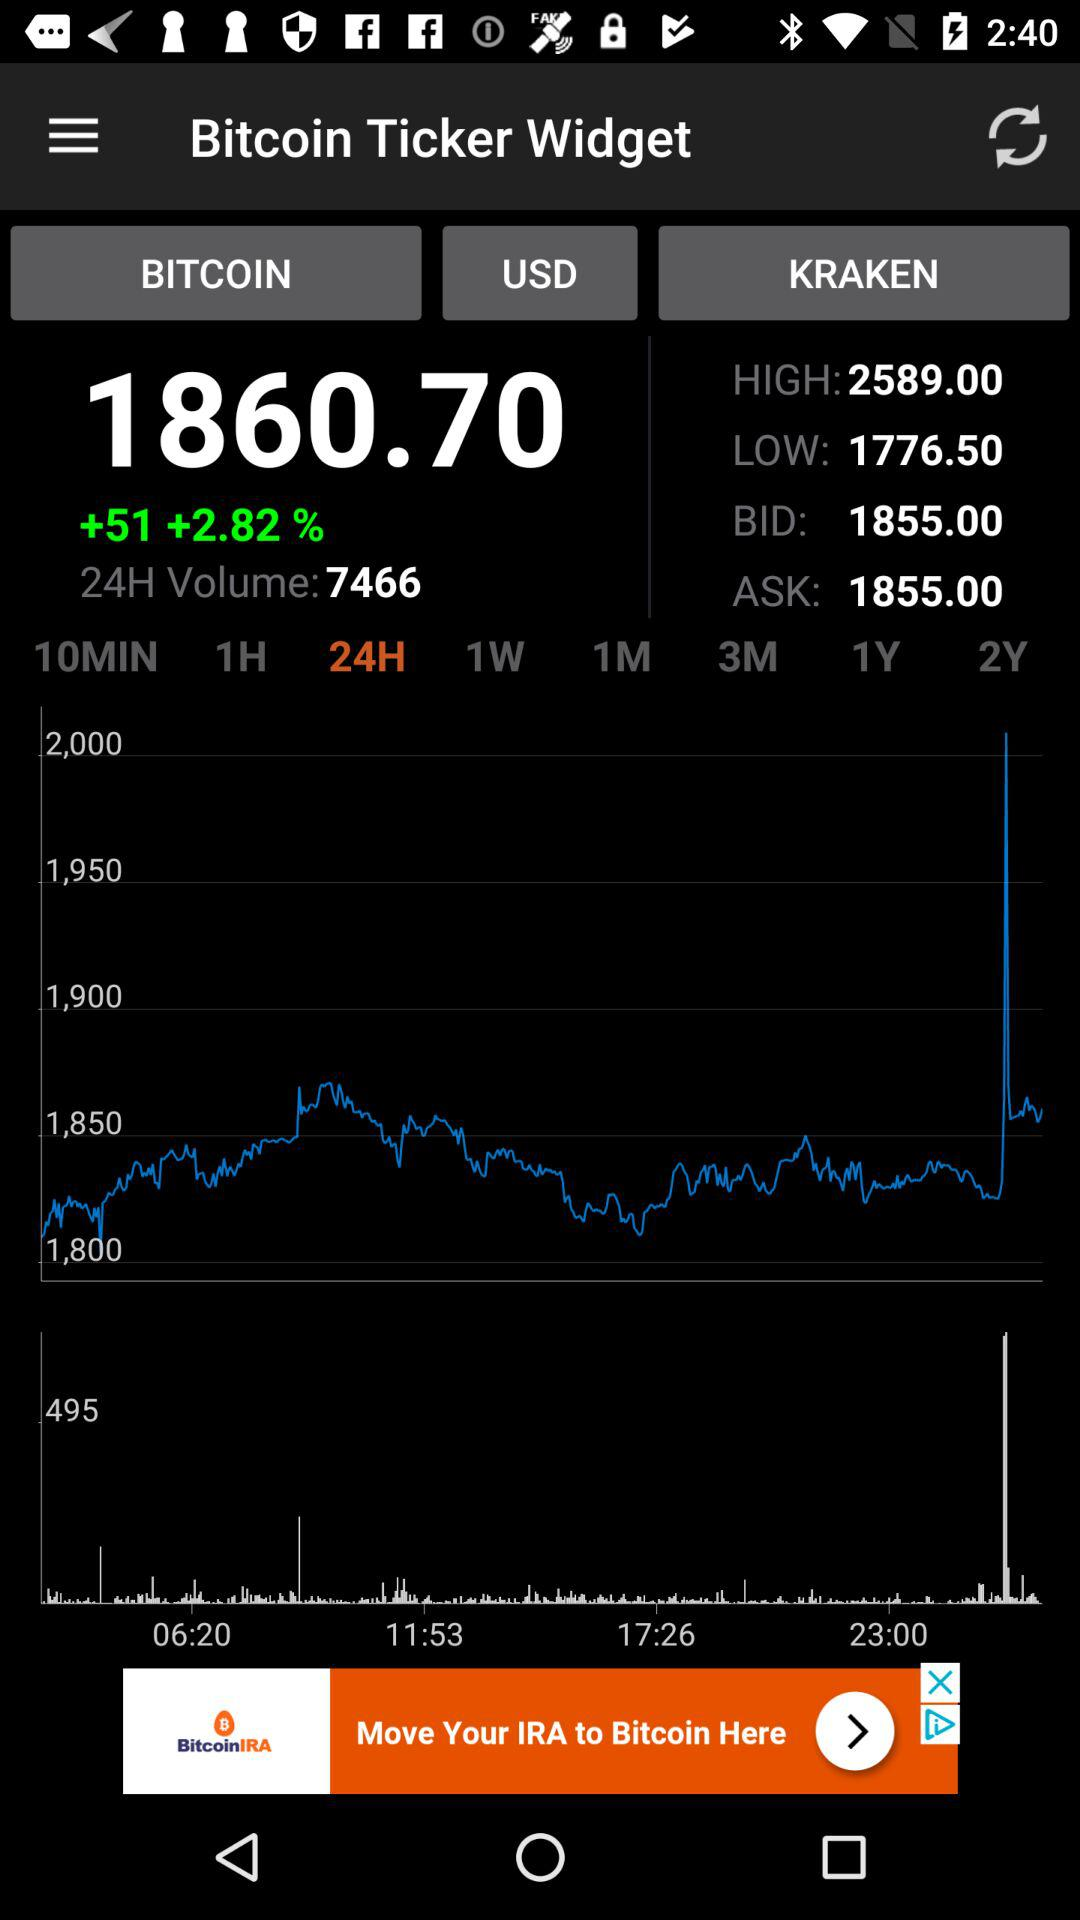What is the highest kraken? The highest kraken is 2589. 